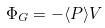Convert formula to latex. <formula><loc_0><loc_0><loc_500><loc_500>\Phi _ { G } = - \langle P \rangle V</formula> 